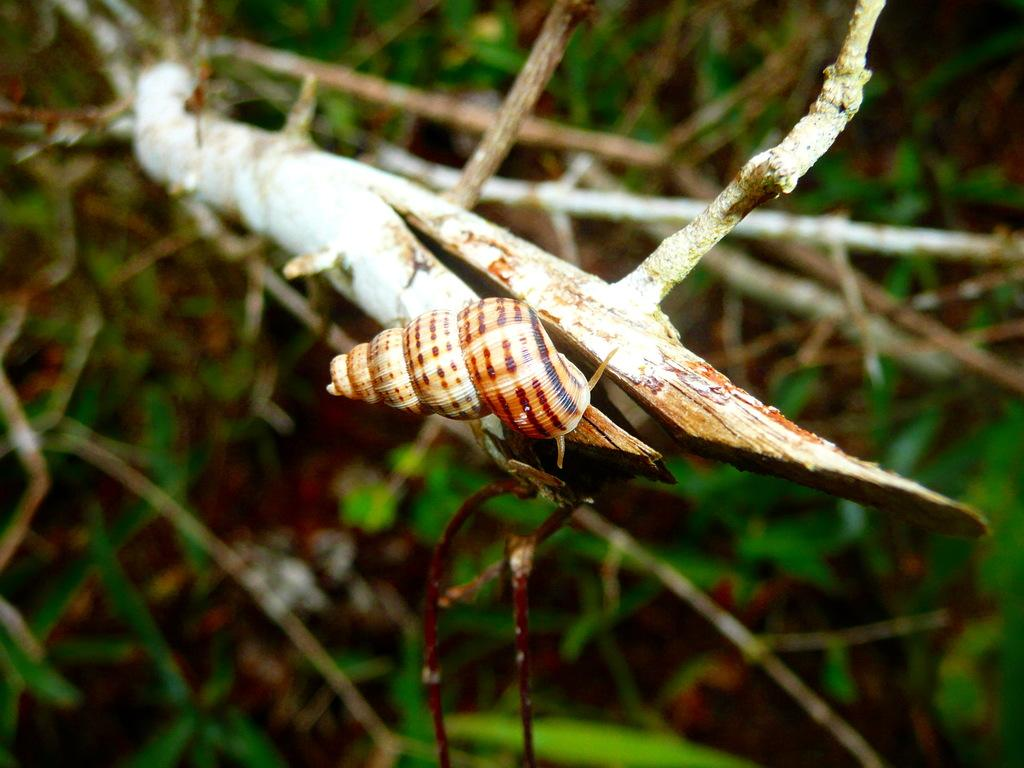What type of animal is in the image? There is a snail in the image. What is the snail resting on? The snail is on a wooden stick. Can you describe the background of the image? The background of the image is blurred. What type of meat is being served in the office in the image? There is no meat or office present in the image; it features a snail on a wooden stick with a blurred background. 